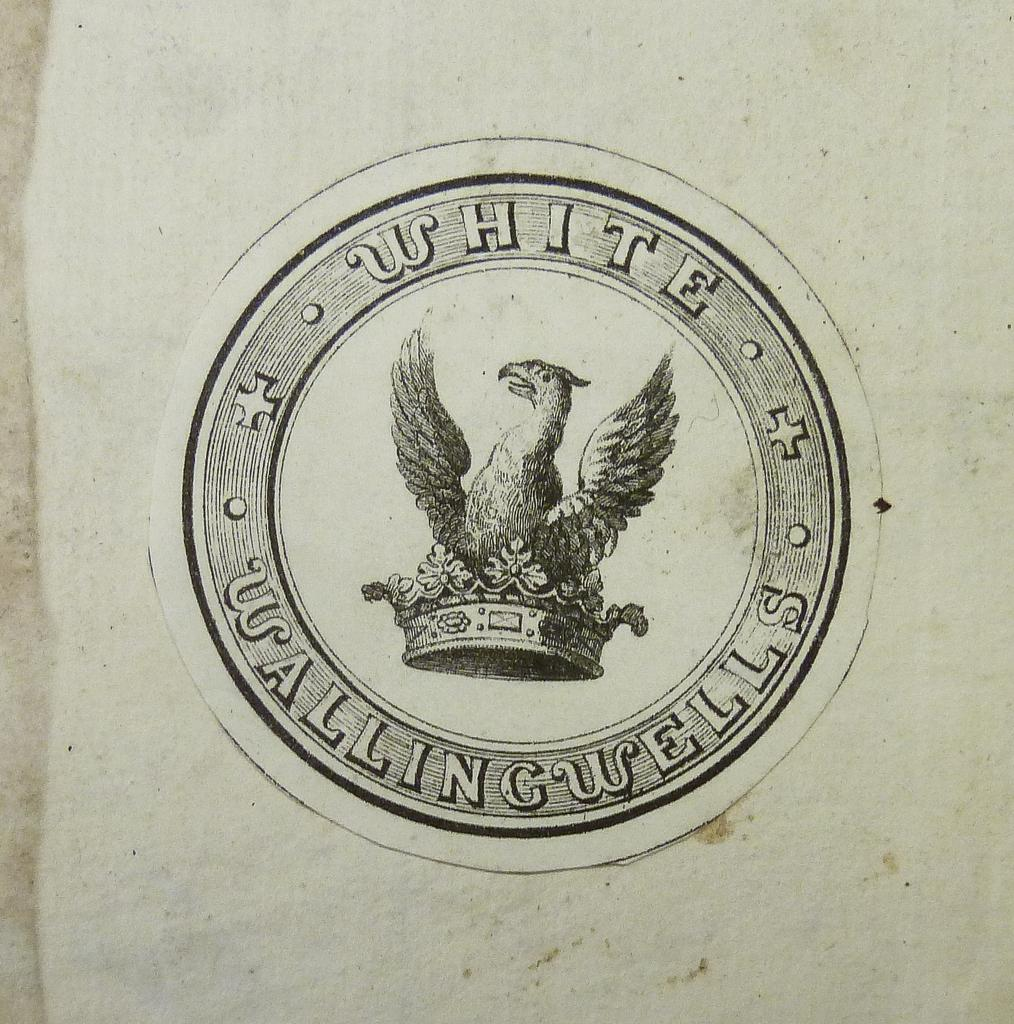What object is the main focus of the image? There is a stamp in the image. Where is the stamp located? The stamp is on a surface. What is depicted on the stamp? There is a bird and a crown depicted on the stamp. What type of instrument is being played by the maid in the image? There is no maid or instrument present in the image; it only features a stamp with a bird and a crown. 